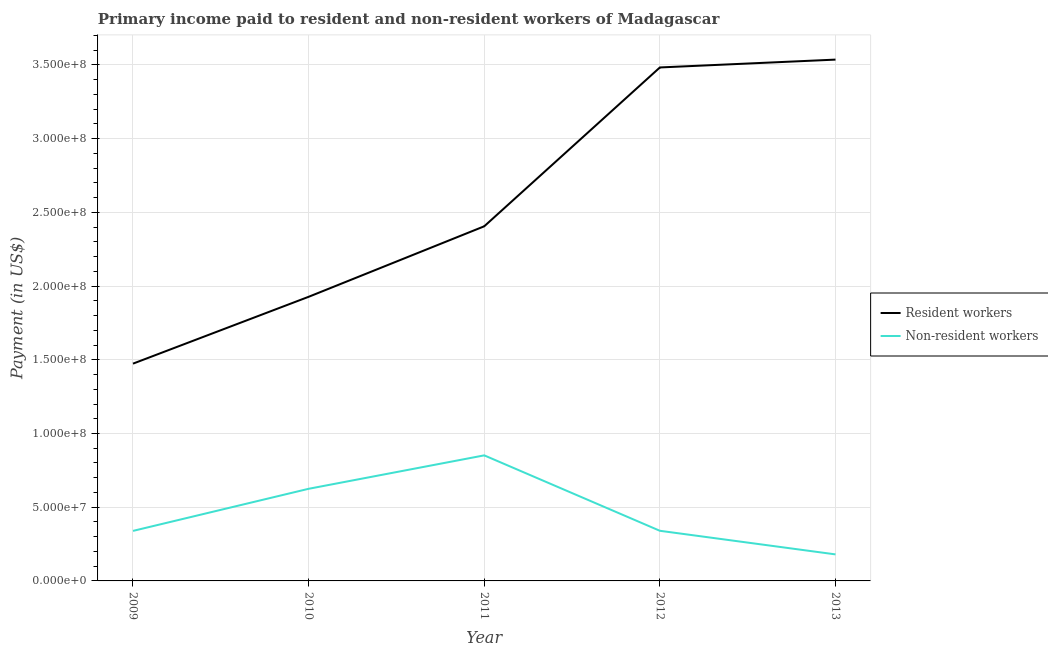How many different coloured lines are there?
Keep it short and to the point. 2. Is the number of lines equal to the number of legend labels?
Your answer should be compact. Yes. What is the payment made to non-resident workers in 2013?
Your answer should be very brief. 1.80e+07. Across all years, what is the maximum payment made to resident workers?
Keep it short and to the point. 3.54e+08. Across all years, what is the minimum payment made to resident workers?
Keep it short and to the point. 1.47e+08. What is the total payment made to resident workers in the graph?
Your answer should be very brief. 1.28e+09. What is the difference between the payment made to resident workers in 2010 and that in 2012?
Provide a short and direct response. -1.56e+08. What is the difference between the payment made to resident workers in 2011 and the payment made to non-resident workers in 2009?
Offer a terse response. 2.07e+08. What is the average payment made to resident workers per year?
Ensure brevity in your answer.  2.57e+08. In the year 2012, what is the difference between the payment made to non-resident workers and payment made to resident workers?
Offer a very short reply. -3.14e+08. In how many years, is the payment made to non-resident workers greater than 360000000 US$?
Offer a terse response. 0. What is the ratio of the payment made to non-resident workers in 2010 to that in 2012?
Keep it short and to the point. 1.84. Is the payment made to resident workers in 2011 less than that in 2013?
Give a very brief answer. Yes. Is the difference between the payment made to resident workers in 2009 and 2010 greater than the difference between the payment made to non-resident workers in 2009 and 2010?
Give a very brief answer. No. What is the difference between the highest and the second highest payment made to non-resident workers?
Your answer should be very brief. 2.27e+07. What is the difference between the highest and the lowest payment made to resident workers?
Provide a succinct answer. 2.06e+08. Is the sum of the payment made to resident workers in 2010 and 2013 greater than the maximum payment made to non-resident workers across all years?
Offer a terse response. Yes. Is the payment made to resident workers strictly greater than the payment made to non-resident workers over the years?
Offer a very short reply. Yes. Is the payment made to resident workers strictly less than the payment made to non-resident workers over the years?
Offer a terse response. No. Where does the legend appear in the graph?
Keep it short and to the point. Center right. What is the title of the graph?
Make the answer very short. Primary income paid to resident and non-resident workers of Madagascar. Does "Quality of trade" appear as one of the legend labels in the graph?
Keep it short and to the point. No. What is the label or title of the Y-axis?
Keep it short and to the point. Payment (in US$). What is the Payment (in US$) in Resident workers in 2009?
Make the answer very short. 1.47e+08. What is the Payment (in US$) in Non-resident workers in 2009?
Offer a terse response. 3.39e+07. What is the Payment (in US$) in Resident workers in 2010?
Keep it short and to the point. 1.93e+08. What is the Payment (in US$) in Non-resident workers in 2010?
Make the answer very short. 6.25e+07. What is the Payment (in US$) of Resident workers in 2011?
Make the answer very short. 2.41e+08. What is the Payment (in US$) in Non-resident workers in 2011?
Give a very brief answer. 8.52e+07. What is the Payment (in US$) of Resident workers in 2012?
Offer a terse response. 3.48e+08. What is the Payment (in US$) in Non-resident workers in 2012?
Offer a terse response. 3.40e+07. What is the Payment (in US$) in Resident workers in 2013?
Provide a succinct answer. 3.54e+08. What is the Payment (in US$) of Non-resident workers in 2013?
Ensure brevity in your answer.  1.80e+07. Across all years, what is the maximum Payment (in US$) of Resident workers?
Your response must be concise. 3.54e+08. Across all years, what is the maximum Payment (in US$) of Non-resident workers?
Ensure brevity in your answer.  8.52e+07. Across all years, what is the minimum Payment (in US$) in Resident workers?
Offer a terse response. 1.47e+08. Across all years, what is the minimum Payment (in US$) of Non-resident workers?
Provide a succinct answer. 1.80e+07. What is the total Payment (in US$) of Resident workers in the graph?
Your answer should be compact. 1.28e+09. What is the total Payment (in US$) of Non-resident workers in the graph?
Provide a succinct answer. 2.34e+08. What is the difference between the Payment (in US$) of Resident workers in 2009 and that in 2010?
Keep it short and to the point. -4.53e+07. What is the difference between the Payment (in US$) of Non-resident workers in 2009 and that in 2010?
Offer a terse response. -2.86e+07. What is the difference between the Payment (in US$) of Resident workers in 2009 and that in 2011?
Offer a very short reply. -9.32e+07. What is the difference between the Payment (in US$) in Non-resident workers in 2009 and that in 2011?
Your answer should be very brief. -5.12e+07. What is the difference between the Payment (in US$) of Resident workers in 2009 and that in 2012?
Your response must be concise. -2.01e+08. What is the difference between the Payment (in US$) in Non-resident workers in 2009 and that in 2012?
Your answer should be compact. -7.37e+04. What is the difference between the Payment (in US$) in Resident workers in 2009 and that in 2013?
Keep it short and to the point. -2.06e+08. What is the difference between the Payment (in US$) in Non-resident workers in 2009 and that in 2013?
Your answer should be very brief. 1.59e+07. What is the difference between the Payment (in US$) in Resident workers in 2010 and that in 2011?
Offer a terse response. -4.78e+07. What is the difference between the Payment (in US$) of Non-resident workers in 2010 and that in 2011?
Provide a succinct answer. -2.27e+07. What is the difference between the Payment (in US$) of Resident workers in 2010 and that in 2012?
Your answer should be very brief. -1.56e+08. What is the difference between the Payment (in US$) of Non-resident workers in 2010 and that in 2012?
Provide a succinct answer. 2.85e+07. What is the difference between the Payment (in US$) of Resident workers in 2010 and that in 2013?
Offer a very short reply. -1.61e+08. What is the difference between the Payment (in US$) in Non-resident workers in 2010 and that in 2013?
Offer a very short reply. 4.45e+07. What is the difference between the Payment (in US$) of Resident workers in 2011 and that in 2012?
Offer a terse response. -1.08e+08. What is the difference between the Payment (in US$) in Non-resident workers in 2011 and that in 2012?
Your answer should be compact. 5.12e+07. What is the difference between the Payment (in US$) in Resident workers in 2011 and that in 2013?
Provide a succinct answer. -1.13e+08. What is the difference between the Payment (in US$) of Non-resident workers in 2011 and that in 2013?
Offer a very short reply. 6.72e+07. What is the difference between the Payment (in US$) of Resident workers in 2012 and that in 2013?
Keep it short and to the point. -5.32e+06. What is the difference between the Payment (in US$) in Non-resident workers in 2012 and that in 2013?
Your answer should be very brief. 1.60e+07. What is the difference between the Payment (in US$) in Resident workers in 2009 and the Payment (in US$) in Non-resident workers in 2010?
Make the answer very short. 8.49e+07. What is the difference between the Payment (in US$) in Resident workers in 2009 and the Payment (in US$) in Non-resident workers in 2011?
Your answer should be compact. 6.22e+07. What is the difference between the Payment (in US$) in Resident workers in 2009 and the Payment (in US$) in Non-resident workers in 2012?
Offer a very short reply. 1.13e+08. What is the difference between the Payment (in US$) of Resident workers in 2009 and the Payment (in US$) of Non-resident workers in 2013?
Make the answer very short. 1.29e+08. What is the difference between the Payment (in US$) in Resident workers in 2010 and the Payment (in US$) in Non-resident workers in 2011?
Provide a succinct answer. 1.08e+08. What is the difference between the Payment (in US$) of Resident workers in 2010 and the Payment (in US$) of Non-resident workers in 2012?
Your response must be concise. 1.59e+08. What is the difference between the Payment (in US$) in Resident workers in 2010 and the Payment (in US$) in Non-resident workers in 2013?
Provide a short and direct response. 1.75e+08. What is the difference between the Payment (in US$) of Resident workers in 2011 and the Payment (in US$) of Non-resident workers in 2012?
Your answer should be compact. 2.07e+08. What is the difference between the Payment (in US$) in Resident workers in 2011 and the Payment (in US$) in Non-resident workers in 2013?
Your answer should be compact. 2.23e+08. What is the difference between the Payment (in US$) in Resident workers in 2012 and the Payment (in US$) in Non-resident workers in 2013?
Ensure brevity in your answer.  3.30e+08. What is the average Payment (in US$) in Resident workers per year?
Give a very brief answer. 2.57e+08. What is the average Payment (in US$) in Non-resident workers per year?
Ensure brevity in your answer.  4.67e+07. In the year 2009, what is the difference between the Payment (in US$) in Resident workers and Payment (in US$) in Non-resident workers?
Give a very brief answer. 1.13e+08. In the year 2010, what is the difference between the Payment (in US$) of Resident workers and Payment (in US$) of Non-resident workers?
Offer a terse response. 1.30e+08. In the year 2011, what is the difference between the Payment (in US$) of Resident workers and Payment (in US$) of Non-resident workers?
Your response must be concise. 1.55e+08. In the year 2012, what is the difference between the Payment (in US$) of Resident workers and Payment (in US$) of Non-resident workers?
Offer a terse response. 3.14e+08. In the year 2013, what is the difference between the Payment (in US$) in Resident workers and Payment (in US$) in Non-resident workers?
Ensure brevity in your answer.  3.36e+08. What is the ratio of the Payment (in US$) in Resident workers in 2009 to that in 2010?
Keep it short and to the point. 0.76. What is the ratio of the Payment (in US$) of Non-resident workers in 2009 to that in 2010?
Offer a terse response. 0.54. What is the ratio of the Payment (in US$) in Resident workers in 2009 to that in 2011?
Provide a succinct answer. 0.61. What is the ratio of the Payment (in US$) in Non-resident workers in 2009 to that in 2011?
Offer a terse response. 0.4. What is the ratio of the Payment (in US$) of Resident workers in 2009 to that in 2012?
Ensure brevity in your answer.  0.42. What is the ratio of the Payment (in US$) of Non-resident workers in 2009 to that in 2012?
Offer a very short reply. 1. What is the ratio of the Payment (in US$) of Resident workers in 2009 to that in 2013?
Provide a short and direct response. 0.42. What is the ratio of the Payment (in US$) in Non-resident workers in 2009 to that in 2013?
Keep it short and to the point. 1.89. What is the ratio of the Payment (in US$) of Resident workers in 2010 to that in 2011?
Your answer should be very brief. 0.8. What is the ratio of the Payment (in US$) of Non-resident workers in 2010 to that in 2011?
Provide a short and direct response. 0.73. What is the ratio of the Payment (in US$) of Resident workers in 2010 to that in 2012?
Offer a terse response. 0.55. What is the ratio of the Payment (in US$) in Non-resident workers in 2010 to that in 2012?
Your response must be concise. 1.84. What is the ratio of the Payment (in US$) of Resident workers in 2010 to that in 2013?
Offer a terse response. 0.55. What is the ratio of the Payment (in US$) of Non-resident workers in 2010 to that in 2013?
Provide a succinct answer. 3.47. What is the ratio of the Payment (in US$) of Resident workers in 2011 to that in 2012?
Make the answer very short. 0.69. What is the ratio of the Payment (in US$) in Non-resident workers in 2011 to that in 2012?
Offer a very short reply. 2.5. What is the ratio of the Payment (in US$) in Resident workers in 2011 to that in 2013?
Provide a succinct answer. 0.68. What is the ratio of the Payment (in US$) in Non-resident workers in 2011 to that in 2013?
Keep it short and to the point. 4.73. What is the ratio of the Payment (in US$) of Non-resident workers in 2012 to that in 2013?
Ensure brevity in your answer.  1.89. What is the difference between the highest and the second highest Payment (in US$) of Resident workers?
Make the answer very short. 5.32e+06. What is the difference between the highest and the second highest Payment (in US$) of Non-resident workers?
Make the answer very short. 2.27e+07. What is the difference between the highest and the lowest Payment (in US$) in Resident workers?
Your answer should be very brief. 2.06e+08. What is the difference between the highest and the lowest Payment (in US$) in Non-resident workers?
Give a very brief answer. 6.72e+07. 